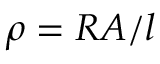<formula> <loc_0><loc_0><loc_500><loc_500>\rho = R A / l</formula> 